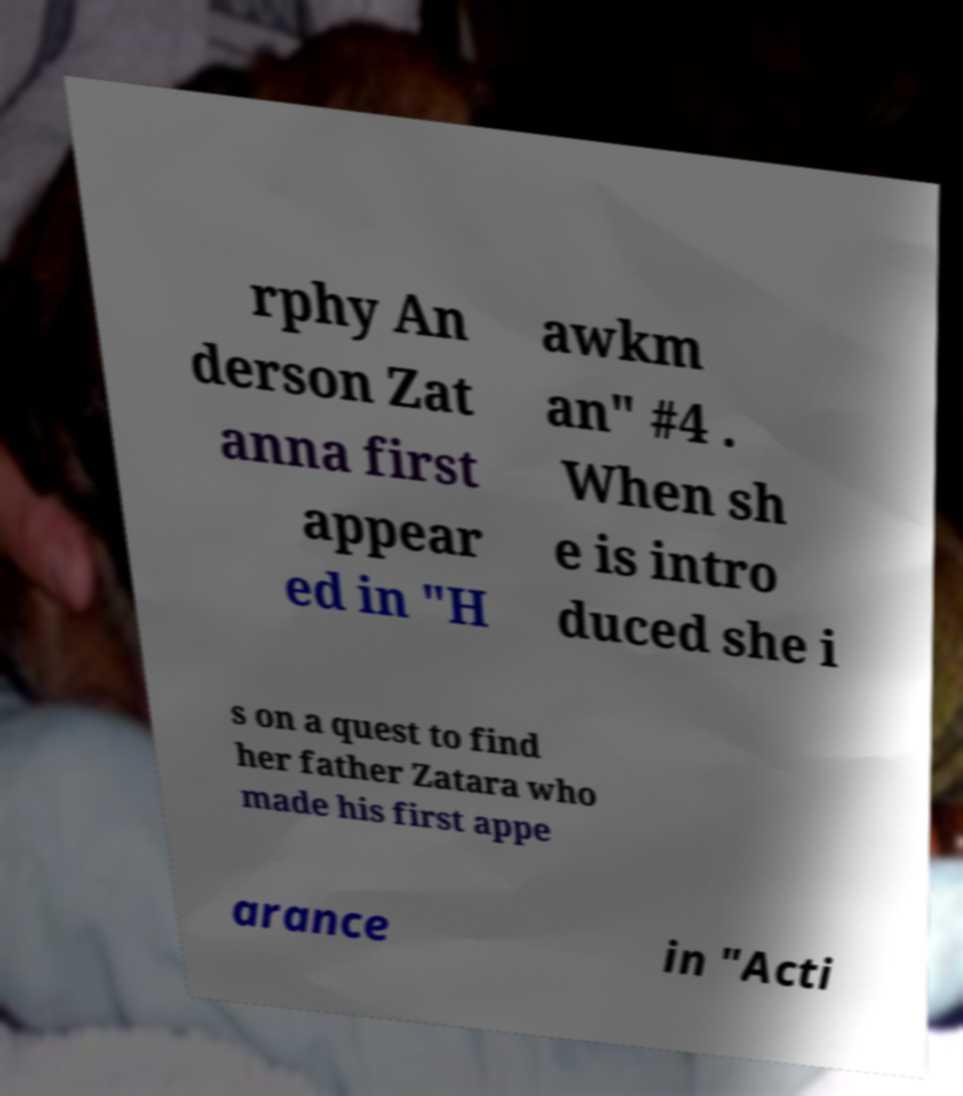What messages or text are displayed in this image? I need them in a readable, typed format. rphy An derson Zat anna first appear ed in "H awkm an" #4 . When sh e is intro duced she i s on a quest to find her father Zatara who made his first appe arance in "Acti 